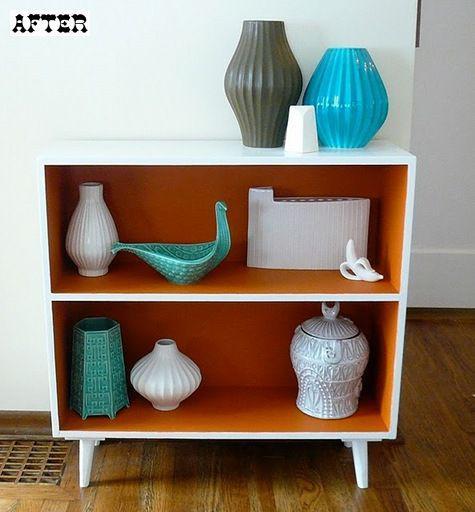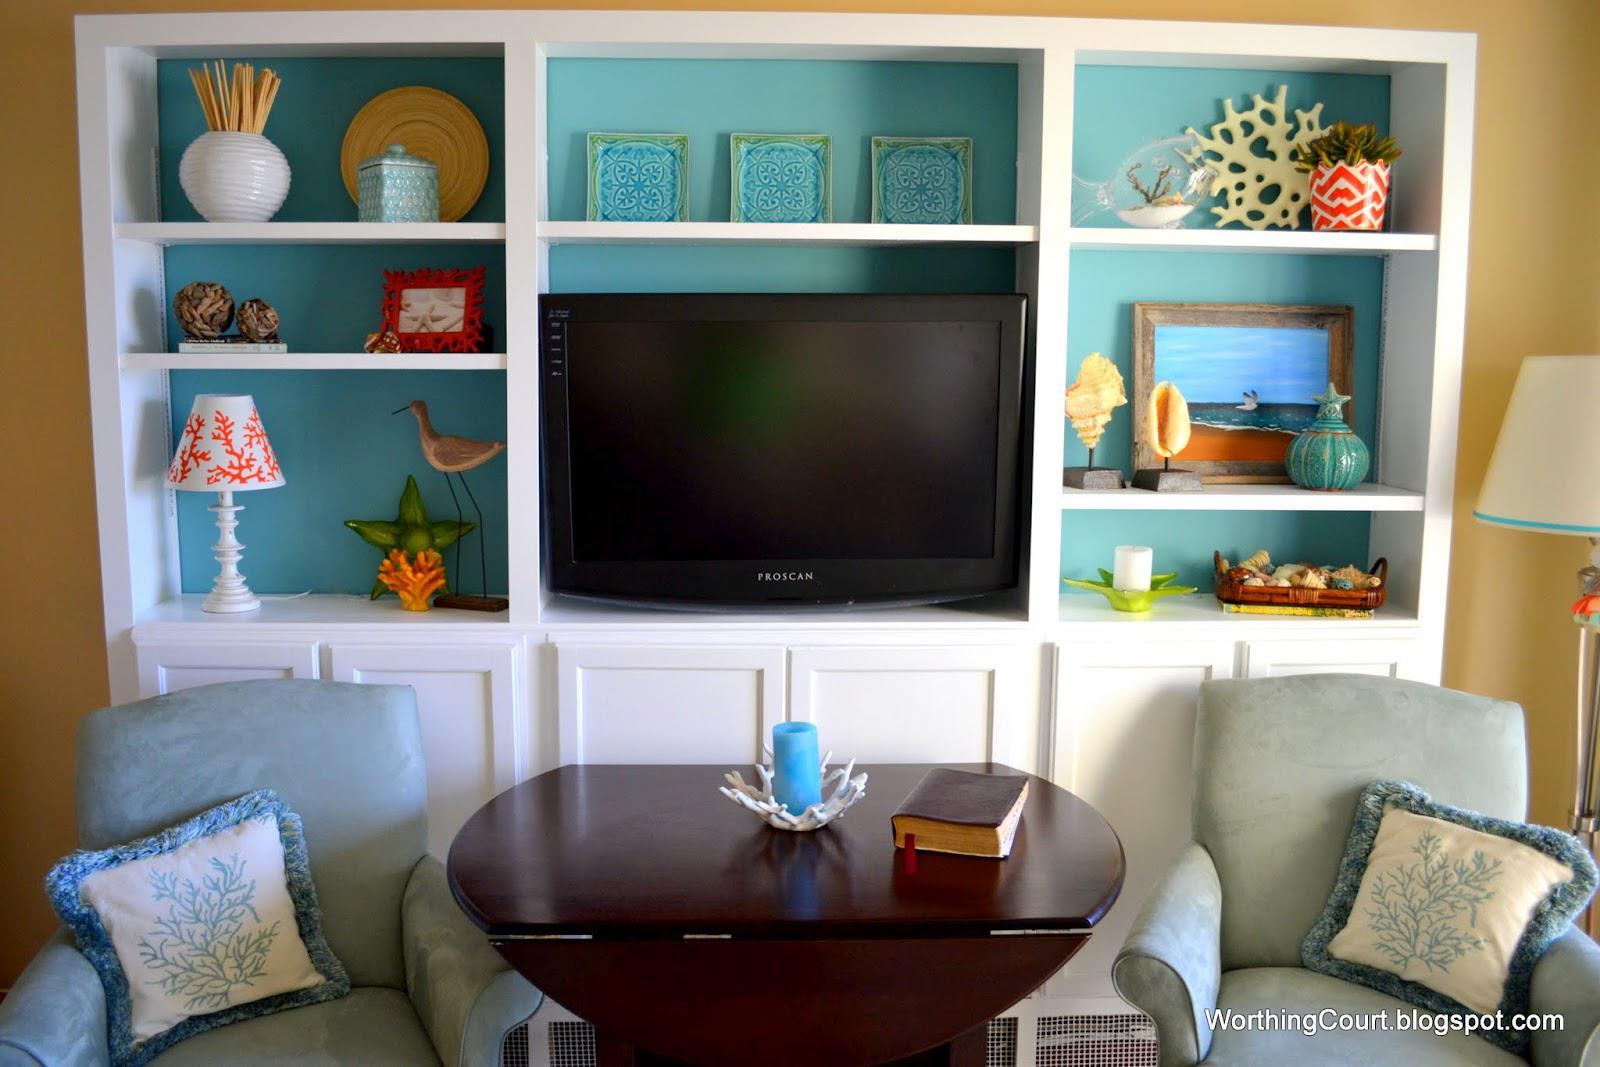The first image is the image on the left, the second image is the image on the right. Given the left and right images, does the statement "At least one image shows a white cabinet containing some type of sky blue ceramic vessel." hold true? Answer yes or no. Yes. 